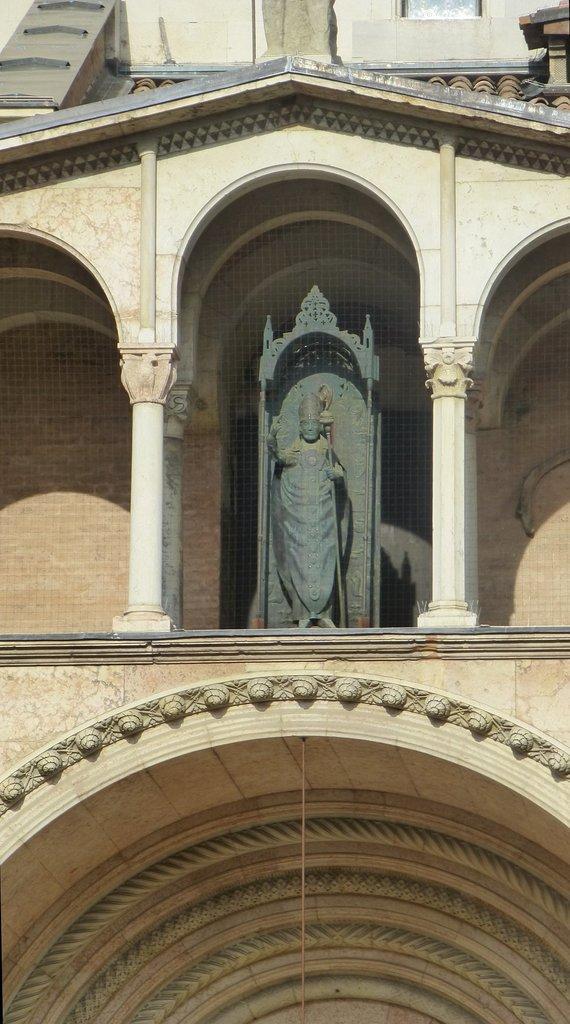Can you describe this image briefly? In this image I can see the statue. In the background, I can see the wall. 